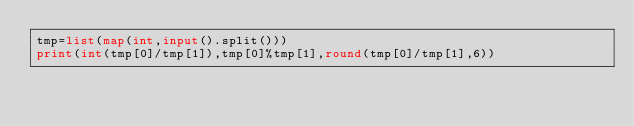<code> <loc_0><loc_0><loc_500><loc_500><_Python_>tmp=list(map(int,input().split()))
print(int(tmp[0]/tmp[1]),tmp[0]%tmp[1],round(tmp[0]/tmp[1],6))

</code> 